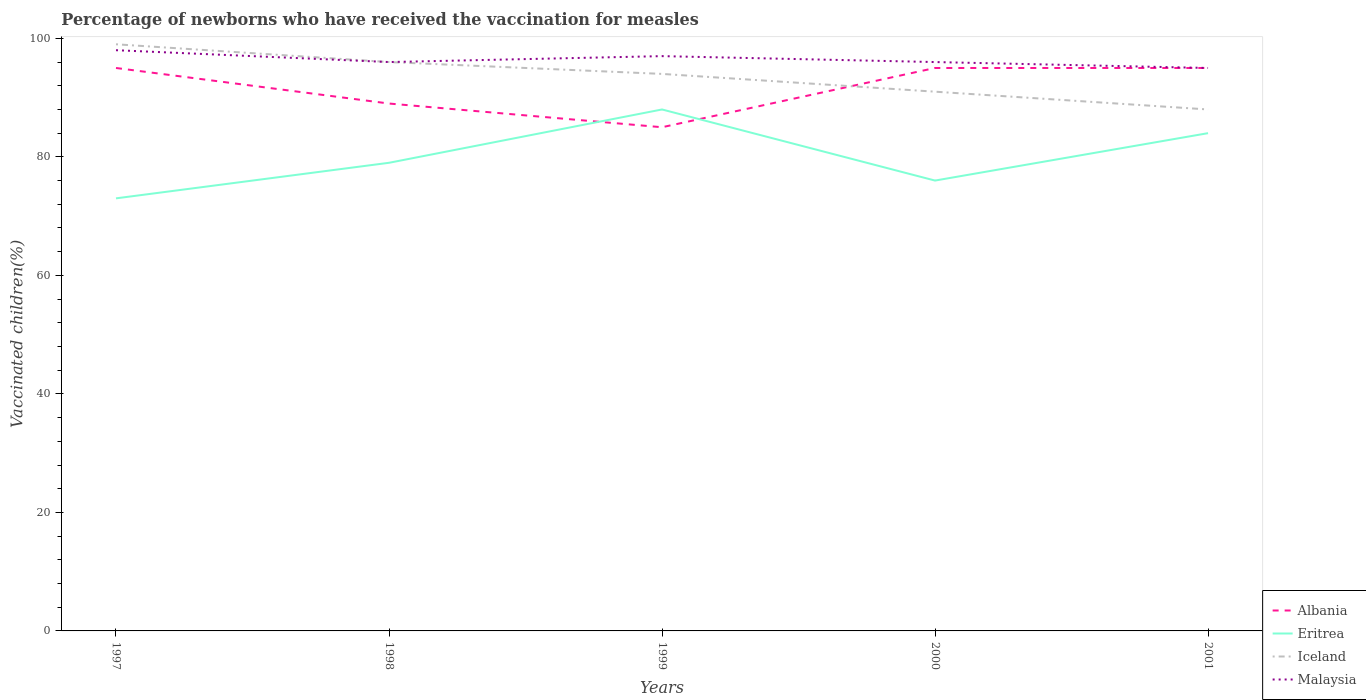Does the line corresponding to Iceland intersect with the line corresponding to Malaysia?
Provide a short and direct response. Yes. Is the number of lines equal to the number of legend labels?
Your answer should be very brief. Yes. Across all years, what is the maximum percentage of vaccinated children in Iceland?
Your answer should be compact. 88. In which year was the percentage of vaccinated children in Eritrea maximum?
Offer a terse response. 1997. What is the total percentage of vaccinated children in Albania in the graph?
Offer a very short reply. 10. What is the difference between the highest and the lowest percentage of vaccinated children in Malaysia?
Make the answer very short. 2. Is the percentage of vaccinated children in Eritrea strictly greater than the percentage of vaccinated children in Iceland over the years?
Offer a terse response. Yes. What is the difference between two consecutive major ticks on the Y-axis?
Make the answer very short. 20. Does the graph contain any zero values?
Offer a terse response. No. Does the graph contain grids?
Provide a short and direct response. No. Where does the legend appear in the graph?
Your answer should be compact. Bottom right. How many legend labels are there?
Offer a very short reply. 4. How are the legend labels stacked?
Ensure brevity in your answer.  Vertical. What is the title of the graph?
Keep it short and to the point. Percentage of newborns who have received the vaccination for measles. Does "Bhutan" appear as one of the legend labels in the graph?
Provide a succinct answer. No. What is the label or title of the Y-axis?
Provide a short and direct response. Vaccinated children(%). What is the Vaccinated children(%) in Albania in 1997?
Your answer should be compact. 95. What is the Vaccinated children(%) of Iceland in 1997?
Your response must be concise. 99. What is the Vaccinated children(%) in Malaysia in 1997?
Ensure brevity in your answer.  98. What is the Vaccinated children(%) in Albania in 1998?
Offer a terse response. 89. What is the Vaccinated children(%) in Eritrea in 1998?
Provide a short and direct response. 79. What is the Vaccinated children(%) in Iceland in 1998?
Provide a succinct answer. 96. What is the Vaccinated children(%) of Malaysia in 1998?
Ensure brevity in your answer.  96. What is the Vaccinated children(%) of Albania in 1999?
Provide a succinct answer. 85. What is the Vaccinated children(%) of Iceland in 1999?
Keep it short and to the point. 94. What is the Vaccinated children(%) in Malaysia in 1999?
Your response must be concise. 97. What is the Vaccinated children(%) of Albania in 2000?
Keep it short and to the point. 95. What is the Vaccinated children(%) of Iceland in 2000?
Your answer should be very brief. 91. What is the Vaccinated children(%) of Malaysia in 2000?
Offer a very short reply. 96. What is the Vaccinated children(%) in Albania in 2001?
Your answer should be compact. 95. What is the Vaccinated children(%) of Iceland in 2001?
Make the answer very short. 88. Across all years, what is the maximum Vaccinated children(%) of Albania?
Offer a very short reply. 95. Across all years, what is the maximum Vaccinated children(%) of Iceland?
Make the answer very short. 99. Across all years, what is the maximum Vaccinated children(%) in Malaysia?
Ensure brevity in your answer.  98. Across all years, what is the minimum Vaccinated children(%) in Eritrea?
Provide a short and direct response. 73. Across all years, what is the minimum Vaccinated children(%) of Malaysia?
Ensure brevity in your answer.  95. What is the total Vaccinated children(%) of Albania in the graph?
Provide a short and direct response. 459. What is the total Vaccinated children(%) of Iceland in the graph?
Your answer should be compact. 468. What is the total Vaccinated children(%) in Malaysia in the graph?
Offer a very short reply. 482. What is the difference between the Vaccinated children(%) in Albania in 1997 and that in 1998?
Your response must be concise. 6. What is the difference between the Vaccinated children(%) in Eritrea in 1997 and that in 1998?
Your response must be concise. -6. What is the difference between the Vaccinated children(%) in Eritrea in 1997 and that in 1999?
Your answer should be compact. -15. What is the difference between the Vaccinated children(%) in Iceland in 1997 and that in 1999?
Your answer should be compact. 5. What is the difference between the Vaccinated children(%) of Malaysia in 1997 and that in 1999?
Make the answer very short. 1. What is the difference between the Vaccinated children(%) of Eritrea in 1997 and that in 2000?
Make the answer very short. -3. What is the difference between the Vaccinated children(%) in Malaysia in 1997 and that in 2000?
Offer a terse response. 2. What is the difference between the Vaccinated children(%) of Iceland in 1997 and that in 2001?
Provide a succinct answer. 11. What is the difference between the Vaccinated children(%) of Malaysia in 1997 and that in 2001?
Keep it short and to the point. 3. What is the difference between the Vaccinated children(%) in Albania in 1998 and that in 1999?
Give a very brief answer. 4. What is the difference between the Vaccinated children(%) in Malaysia in 1998 and that in 1999?
Provide a succinct answer. -1. What is the difference between the Vaccinated children(%) in Albania in 1998 and that in 2000?
Ensure brevity in your answer.  -6. What is the difference between the Vaccinated children(%) of Iceland in 1998 and that in 2000?
Provide a succinct answer. 5. What is the difference between the Vaccinated children(%) in Malaysia in 1998 and that in 2000?
Your answer should be compact. 0. What is the difference between the Vaccinated children(%) in Malaysia in 1998 and that in 2001?
Your answer should be compact. 1. What is the difference between the Vaccinated children(%) of Eritrea in 1999 and that in 2001?
Your response must be concise. 4. What is the difference between the Vaccinated children(%) in Iceland in 1999 and that in 2001?
Your answer should be compact. 6. What is the difference between the Vaccinated children(%) in Malaysia in 1999 and that in 2001?
Your answer should be compact. 2. What is the difference between the Vaccinated children(%) of Albania in 2000 and that in 2001?
Ensure brevity in your answer.  0. What is the difference between the Vaccinated children(%) of Iceland in 2000 and that in 2001?
Keep it short and to the point. 3. What is the difference between the Vaccinated children(%) in Malaysia in 2000 and that in 2001?
Your answer should be very brief. 1. What is the difference between the Vaccinated children(%) of Eritrea in 1997 and the Vaccinated children(%) of Iceland in 1998?
Provide a succinct answer. -23. What is the difference between the Vaccinated children(%) of Iceland in 1997 and the Vaccinated children(%) of Malaysia in 1998?
Keep it short and to the point. 3. What is the difference between the Vaccinated children(%) in Albania in 1997 and the Vaccinated children(%) in Eritrea in 1999?
Your answer should be compact. 7. What is the difference between the Vaccinated children(%) in Albania in 1997 and the Vaccinated children(%) in Iceland in 1999?
Your answer should be compact. 1. What is the difference between the Vaccinated children(%) in Albania in 1997 and the Vaccinated children(%) in Malaysia in 1999?
Ensure brevity in your answer.  -2. What is the difference between the Vaccinated children(%) in Eritrea in 1997 and the Vaccinated children(%) in Iceland in 1999?
Make the answer very short. -21. What is the difference between the Vaccinated children(%) of Eritrea in 1997 and the Vaccinated children(%) of Malaysia in 1999?
Provide a succinct answer. -24. What is the difference between the Vaccinated children(%) of Albania in 1997 and the Vaccinated children(%) of Eritrea in 2000?
Give a very brief answer. 19. What is the difference between the Vaccinated children(%) of Albania in 1997 and the Vaccinated children(%) of Iceland in 2000?
Ensure brevity in your answer.  4. What is the difference between the Vaccinated children(%) of Albania in 1997 and the Vaccinated children(%) of Eritrea in 2001?
Provide a short and direct response. 11. What is the difference between the Vaccinated children(%) of Albania in 1997 and the Vaccinated children(%) of Malaysia in 2001?
Provide a succinct answer. 0. What is the difference between the Vaccinated children(%) in Eritrea in 1997 and the Vaccinated children(%) in Iceland in 2001?
Ensure brevity in your answer.  -15. What is the difference between the Vaccinated children(%) in Eritrea in 1997 and the Vaccinated children(%) in Malaysia in 2001?
Offer a terse response. -22. What is the difference between the Vaccinated children(%) in Iceland in 1997 and the Vaccinated children(%) in Malaysia in 2001?
Give a very brief answer. 4. What is the difference between the Vaccinated children(%) in Albania in 1998 and the Vaccinated children(%) in Eritrea in 1999?
Ensure brevity in your answer.  1. What is the difference between the Vaccinated children(%) in Albania in 1998 and the Vaccinated children(%) in Malaysia in 1999?
Offer a terse response. -8. What is the difference between the Vaccinated children(%) of Albania in 1998 and the Vaccinated children(%) of Eritrea in 2000?
Make the answer very short. 13. What is the difference between the Vaccinated children(%) in Eritrea in 1998 and the Vaccinated children(%) in Iceland in 2000?
Your answer should be compact. -12. What is the difference between the Vaccinated children(%) in Albania in 1998 and the Vaccinated children(%) in Iceland in 2001?
Provide a succinct answer. 1. What is the difference between the Vaccinated children(%) in Iceland in 1998 and the Vaccinated children(%) in Malaysia in 2001?
Your answer should be very brief. 1. What is the difference between the Vaccinated children(%) in Albania in 1999 and the Vaccinated children(%) in Iceland in 2000?
Provide a short and direct response. -6. What is the difference between the Vaccinated children(%) in Iceland in 1999 and the Vaccinated children(%) in Malaysia in 2000?
Your answer should be compact. -2. What is the difference between the Vaccinated children(%) in Albania in 1999 and the Vaccinated children(%) in Malaysia in 2001?
Give a very brief answer. -10. What is the difference between the Vaccinated children(%) in Iceland in 1999 and the Vaccinated children(%) in Malaysia in 2001?
Offer a terse response. -1. What is the difference between the Vaccinated children(%) of Albania in 2000 and the Vaccinated children(%) of Eritrea in 2001?
Make the answer very short. 11. What is the difference between the Vaccinated children(%) of Albania in 2000 and the Vaccinated children(%) of Malaysia in 2001?
Your response must be concise. 0. What is the difference between the Vaccinated children(%) in Eritrea in 2000 and the Vaccinated children(%) in Iceland in 2001?
Give a very brief answer. -12. What is the difference between the Vaccinated children(%) in Eritrea in 2000 and the Vaccinated children(%) in Malaysia in 2001?
Your answer should be very brief. -19. What is the average Vaccinated children(%) of Albania per year?
Offer a very short reply. 91.8. What is the average Vaccinated children(%) in Eritrea per year?
Provide a short and direct response. 80. What is the average Vaccinated children(%) in Iceland per year?
Your answer should be compact. 93.6. What is the average Vaccinated children(%) of Malaysia per year?
Give a very brief answer. 96.4. In the year 1997, what is the difference between the Vaccinated children(%) in Albania and Vaccinated children(%) in Eritrea?
Provide a short and direct response. 22. In the year 1997, what is the difference between the Vaccinated children(%) of Albania and Vaccinated children(%) of Iceland?
Provide a succinct answer. -4. In the year 1997, what is the difference between the Vaccinated children(%) of Iceland and Vaccinated children(%) of Malaysia?
Keep it short and to the point. 1. In the year 1998, what is the difference between the Vaccinated children(%) of Albania and Vaccinated children(%) of Malaysia?
Offer a very short reply. -7. In the year 1998, what is the difference between the Vaccinated children(%) in Eritrea and Vaccinated children(%) in Malaysia?
Ensure brevity in your answer.  -17. In the year 1999, what is the difference between the Vaccinated children(%) in Albania and Vaccinated children(%) in Iceland?
Your answer should be compact. -9. In the year 1999, what is the difference between the Vaccinated children(%) in Albania and Vaccinated children(%) in Malaysia?
Offer a very short reply. -12. In the year 2000, what is the difference between the Vaccinated children(%) of Albania and Vaccinated children(%) of Eritrea?
Make the answer very short. 19. In the year 2000, what is the difference between the Vaccinated children(%) of Albania and Vaccinated children(%) of Iceland?
Keep it short and to the point. 4. In the year 2000, what is the difference between the Vaccinated children(%) in Albania and Vaccinated children(%) in Malaysia?
Offer a very short reply. -1. In the year 2000, what is the difference between the Vaccinated children(%) in Eritrea and Vaccinated children(%) in Iceland?
Offer a very short reply. -15. In the year 2000, what is the difference between the Vaccinated children(%) in Eritrea and Vaccinated children(%) in Malaysia?
Make the answer very short. -20. In the year 2000, what is the difference between the Vaccinated children(%) of Iceland and Vaccinated children(%) of Malaysia?
Your response must be concise. -5. In the year 2001, what is the difference between the Vaccinated children(%) of Albania and Vaccinated children(%) of Eritrea?
Your answer should be very brief. 11. In the year 2001, what is the difference between the Vaccinated children(%) in Albania and Vaccinated children(%) in Iceland?
Provide a short and direct response. 7. In the year 2001, what is the difference between the Vaccinated children(%) of Eritrea and Vaccinated children(%) of Malaysia?
Make the answer very short. -11. What is the ratio of the Vaccinated children(%) of Albania in 1997 to that in 1998?
Ensure brevity in your answer.  1.07. What is the ratio of the Vaccinated children(%) of Eritrea in 1997 to that in 1998?
Give a very brief answer. 0.92. What is the ratio of the Vaccinated children(%) in Iceland in 1997 to that in 1998?
Ensure brevity in your answer.  1.03. What is the ratio of the Vaccinated children(%) in Malaysia in 1997 to that in 1998?
Your answer should be very brief. 1.02. What is the ratio of the Vaccinated children(%) of Albania in 1997 to that in 1999?
Provide a succinct answer. 1.12. What is the ratio of the Vaccinated children(%) of Eritrea in 1997 to that in 1999?
Provide a short and direct response. 0.83. What is the ratio of the Vaccinated children(%) in Iceland in 1997 to that in 1999?
Your answer should be compact. 1.05. What is the ratio of the Vaccinated children(%) in Malaysia in 1997 to that in 1999?
Offer a very short reply. 1.01. What is the ratio of the Vaccinated children(%) in Eritrea in 1997 to that in 2000?
Your response must be concise. 0.96. What is the ratio of the Vaccinated children(%) of Iceland in 1997 to that in 2000?
Give a very brief answer. 1.09. What is the ratio of the Vaccinated children(%) of Malaysia in 1997 to that in 2000?
Offer a very short reply. 1.02. What is the ratio of the Vaccinated children(%) in Eritrea in 1997 to that in 2001?
Make the answer very short. 0.87. What is the ratio of the Vaccinated children(%) in Iceland in 1997 to that in 2001?
Your response must be concise. 1.12. What is the ratio of the Vaccinated children(%) in Malaysia in 1997 to that in 2001?
Give a very brief answer. 1.03. What is the ratio of the Vaccinated children(%) in Albania in 1998 to that in 1999?
Give a very brief answer. 1.05. What is the ratio of the Vaccinated children(%) of Eritrea in 1998 to that in 1999?
Keep it short and to the point. 0.9. What is the ratio of the Vaccinated children(%) in Iceland in 1998 to that in 1999?
Keep it short and to the point. 1.02. What is the ratio of the Vaccinated children(%) of Malaysia in 1998 to that in 1999?
Keep it short and to the point. 0.99. What is the ratio of the Vaccinated children(%) in Albania in 1998 to that in 2000?
Your answer should be very brief. 0.94. What is the ratio of the Vaccinated children(%) in Eritrea in 1998 to that in 2000?
Give a very brief answer. 1.04. What is the ratio of the Vaccinated children(%) of Iceland in 1998 to that in 2000?
Make the answer very short. 1.05. What is the ratio of the Vaccinated children(%) in Malaysia in 1998 to that in 2000?
Provide a short and direct response. 1. What is the ratio of the Vaccinated children(%) of Albania in 1998 to that in 2001?
Your answer should be compact. 0.94. What is the ratio of the Vaccinated children(%) of Eritrea in 1998 to that in 2001?
Provide a short and direct response. 0.94. What is the ratio of the Vaccinated children(%) of Malaysia in 1998 to that in 2001?
Provide a short and direct response. 1.01. What is the ratio of the Vaccinated children(%) in Albania in 1999 to that in 2000?
Offer a terse response. 0.89. What is the ratio of the Vaccinated children(%) of Eritrea in 1999 to that in 2000?
Offer a terse response. 1.16. What is the ratio of the Vaccinated children(%) of Iceland in 1999 to that in 2000?
Make the answer very short. 1.03. What is the ratio of the Vaccinated children(%) in Malaysia in 1999 to that in 2000?
Your answer should be very brief. 1.01. What is the ratio of the Vaccinated children(%) of Albania in 1999 to that in 2001?
Your answer should be compact. 0.89. What is the ratio of the Vaccinated children(%) in Eritrea in 1999 to that in 2001?
Give a very brief answer. 1.05. What is the ratio of the Vaccinated children(%) of Iceland in 1999 to that in 2001?
Ensure brevity in your answer.  1.07. What is the ratio of the Vaccinated children(%) in Malaysia in 1999 to that in 2001?
Make the answer very short. 1.02. What is the ratio of the Vaccinated children(%) in Eritrea in 2000 to that in 2001?
Provide a short and direct response. 0.9. What is the ratio of the Vaccinated children(%) of Iceland in 2000 to that in 2001?
Offer a terse response. 1.03. What is the ratio of the Vaccinated children(%) of Malaysia in 2000 to that in 2001?
Ensure brevity in your answer.  1.01. What is the difference between the highest and the lowest Vaccinated children(%) in Albania?
Your answer should be compact. 10. What is the difference between the highest and the lowest Vaccinated children(%) in Eritrea?
Give a very brief answer. 15. 